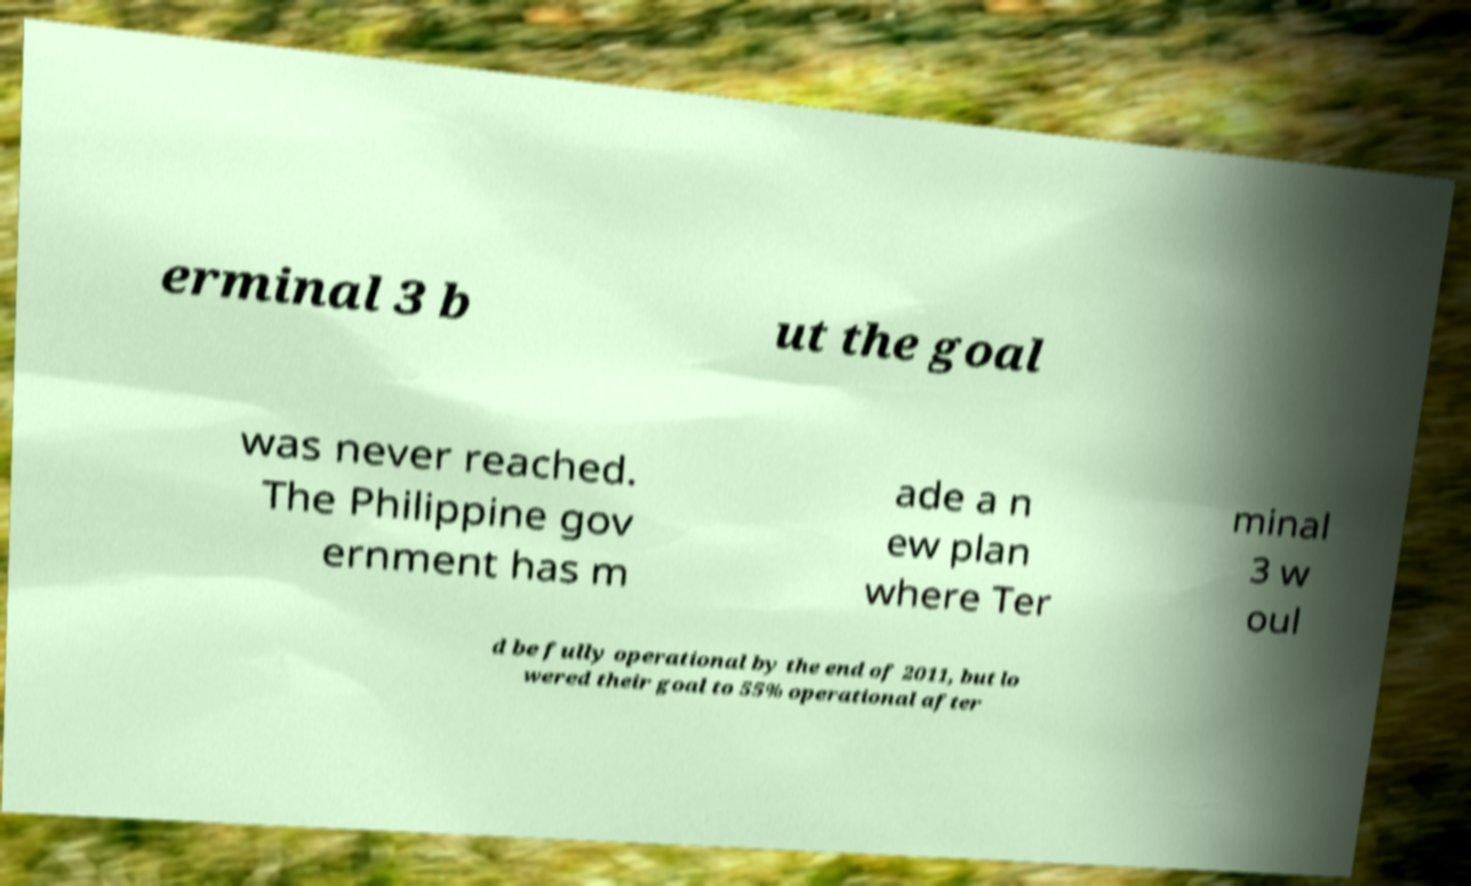There's text embedded in this image that I need extracted. Can you transcribe it verbatim? erminal 3 b ut the goal was never reached. The Philippine gov ernment has m ade a n ew plan where Ter minal 3 w oul d be fully operational by the end of 2011, but lo wered their goal to 55% operational after 